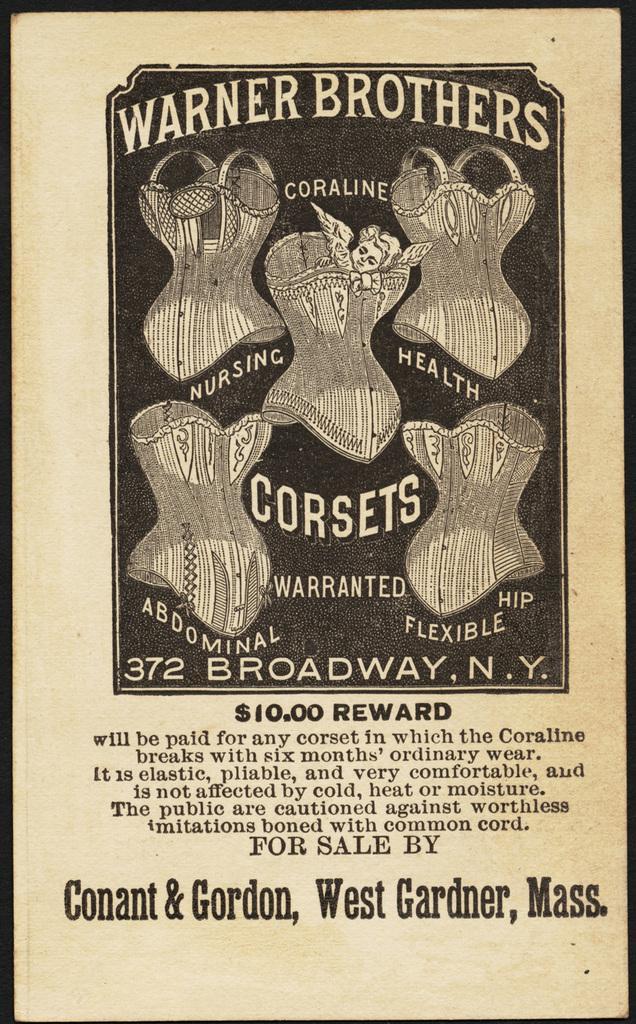How would you summarize this image in a sentence or two? In the center of the image we can see one poster. On the poster, we can see some objects and some text. And we can see the black color border around the image. 